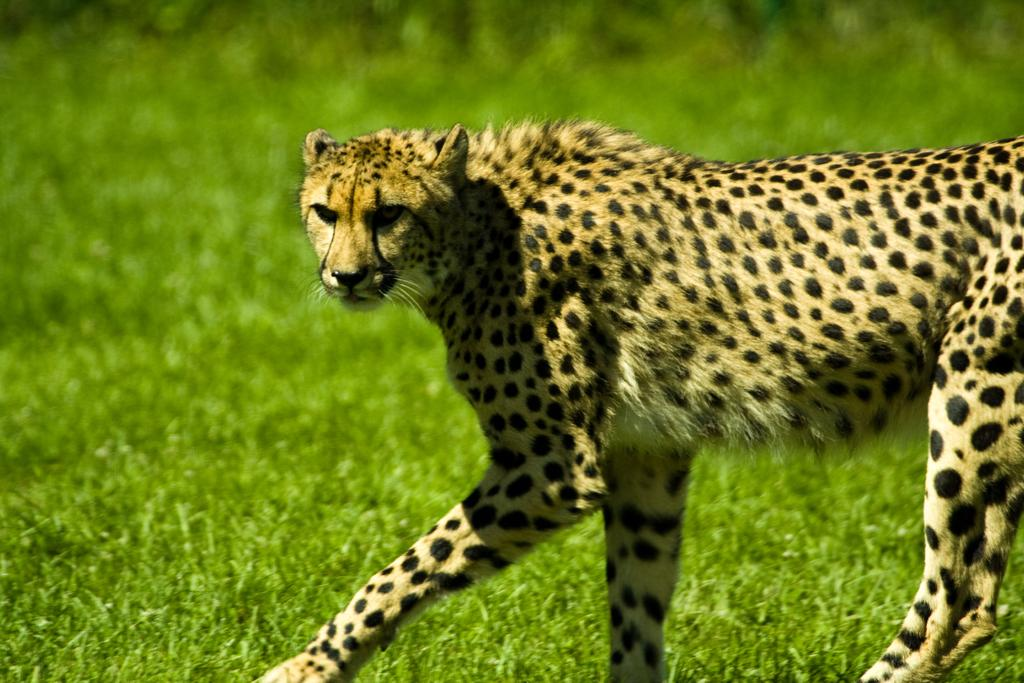What animal is in the image? There is a cheetah in the image. What is the cheetah doing in the image? The cheetah is walking on the ground in the image. What type of vegetation can be seen in the background of the image? There is grass in the background of the image. What type of comfort can be seen in the image? There is no reference to comfort in the image, as it features a cheetah walking on the ground with grass in the background. How many birds are visible in the image? There are no birds present in the image; it features a cheetah walking on the ground with grass in the background. 